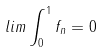<formula> <loc_0><loc_0><loc_500><loc_500>l i m \int _ { 0 } ^ { 1 } f _ { n } = 0</formula> 